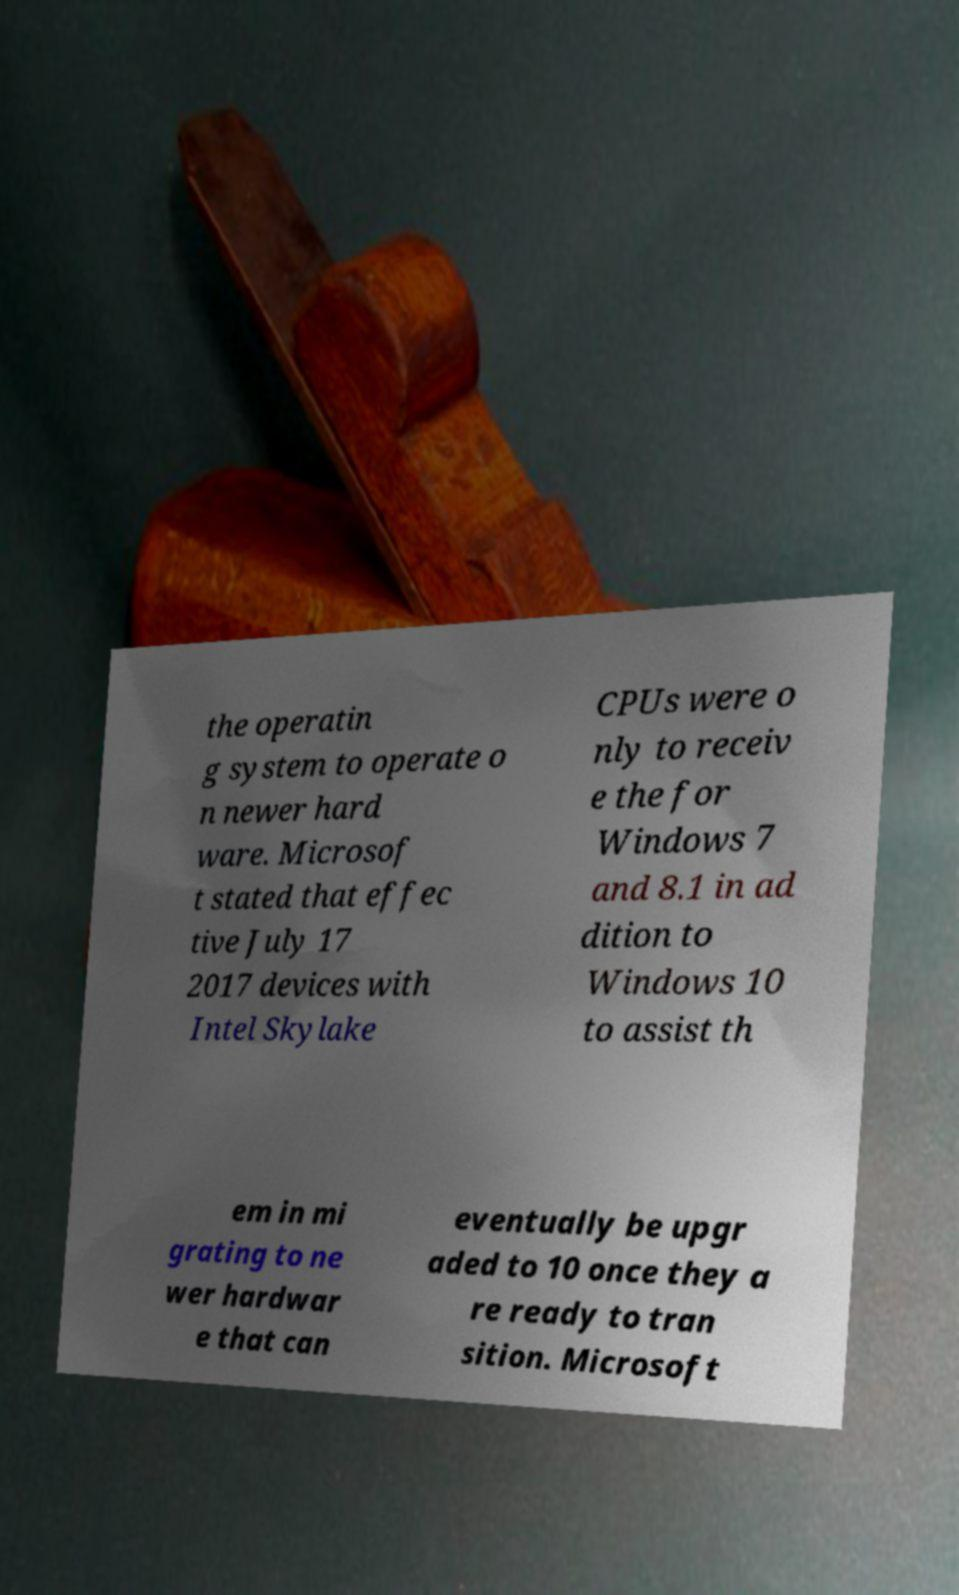What messages or text are displayed in this image? I need them in a readable, typed format. the operatin g system to operate o n newer hard ware. Microsof t stated that effec tive July 17 2017 devices with Intel Skylake CPUs were o nly to receiv e the for Windows 7 and 8.1 in ad dition to Windows 10 to assist th em in mi grating to ne wer hardwar e that can eventually be upgr aded to 10 once they a re ready to tran sition. Microsoft 